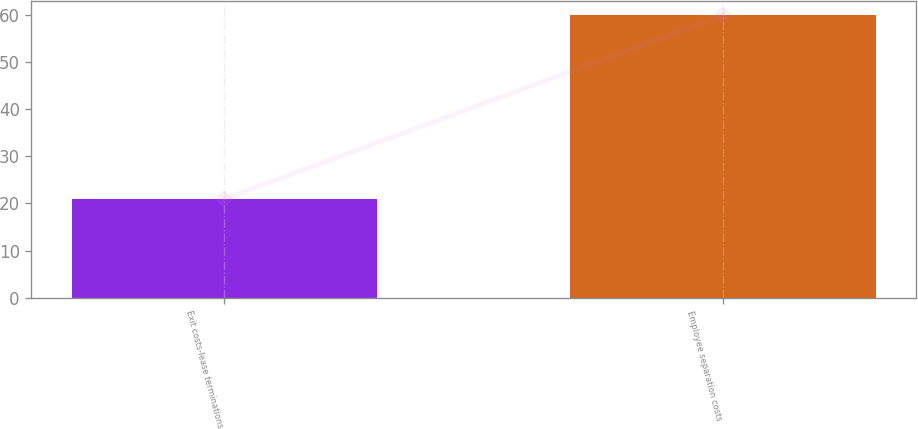Convert chart. <chart><loc_0><loc_0><loc_500><loc_500><bar_chart><fcel>Exit costs-lease terminations<fcel>Employee separation costs<nl><fcel>21<fcel>60<nl></chart> 